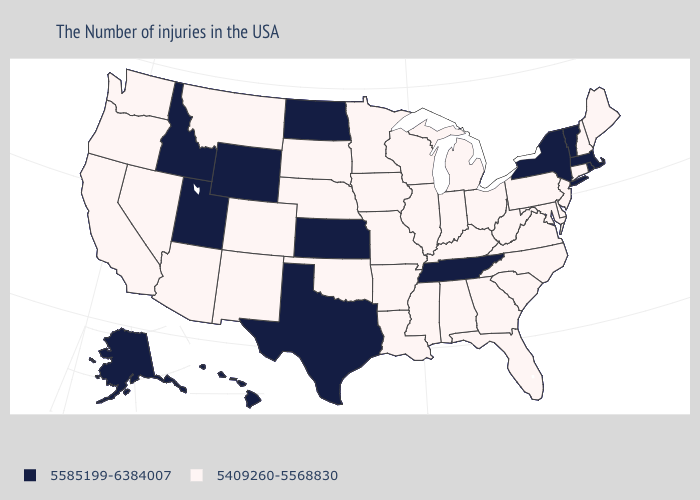What is the lowest value in the MidWest?
Concise answer only. 5409260-5568830. Name the states that have a value in the range 5585199-6384007?
Concise answer only. Massachusetts, Rhode Island, Vermont, New York, Tennessee, Kansas, Texas, North Dakota, Wyoming, Utah, Idaho, Alaska, Hawaii. Is the legend a continuous bar?
Quick response, please. No. Which states have the lowest value in the USA?
Quick response, please. Maine, New Hampshire, Connecticut, New Jersey, Delaware, Maryland, Pennsylvania, Virginia, North Carolina, South Carolina, West Virginia, Ohio, Florida, Georgia, Michigan, Kentucky, Indiana, Alabama, Wisconsin, Illinois, Mississippi, Louisiana, Missouri, Arkansas, Minnesota, Iowa, Nebraska, Oklahoma, South Dakota, Colorado, New Mexico, Montana, Arizona, Nevada, California, Washington, Oregon. Which states have the lowest value in the MidWest?
Concise answer only. Ohio, Michigan, Indiana, Wisconsin, Illinois, Missouri, Minnesota, Iowa, Nebraska, South Dakota. Which states hav the highest value in the South?
Short answer required. Tennessee, Texas. Is the legend a continuous bar?
Short answer required. No. Does Colorado have a lower value than Tennessee?
Answer briefly. Yes. Does Kentucky have the lowest value in the South?
Give a very brief answer. Yes. Name the states that have a value in the range 5409260-5568830?
Give a very brief answer. Maine, New Hampshire, Connecticut, New Jersey, Delaware, Maryland, Pennsylvania, Virginia, North Carolina, South Carolina, West Virginia, Ohio, Florida, Georgia, Michigan, Kentucky, Indiana, Alabama, Wisconsin, Illinois, Mississippi, Louisiana, Missouri, Arkansas, Minnesota, Iowa, Nebraska, Oklahoma, South Dakota, Colorado, New Mexico, Montana, Arizona, Nevada, California, Washington, Oregon. What is the highest value in the West ?
Answer briefly. 5585199-6384007. What is the value of South Dakota?
Short answer required. 5409260-5568830. Name the states that have a value in the range 5585199-6384007?
Keep it brief. Massachusetts, Rhode Island, Vermont, New York, Tennessee, Kansas, Texas, North Dakota, Wyoming, Utah, Idaho, Alaska, Hawaii. Among the states that border Oklahoma , does Missouri have the highest value?
Concise answer only. No. Which states have the highest value in the USA?
Write a very short answer. Massachusetts, Rhode Island, Vermont, New York, Tennessee, Kansas, Texas, North Dakota, Wyoming, Utah, Idaho, Alaska, Hawaii. 